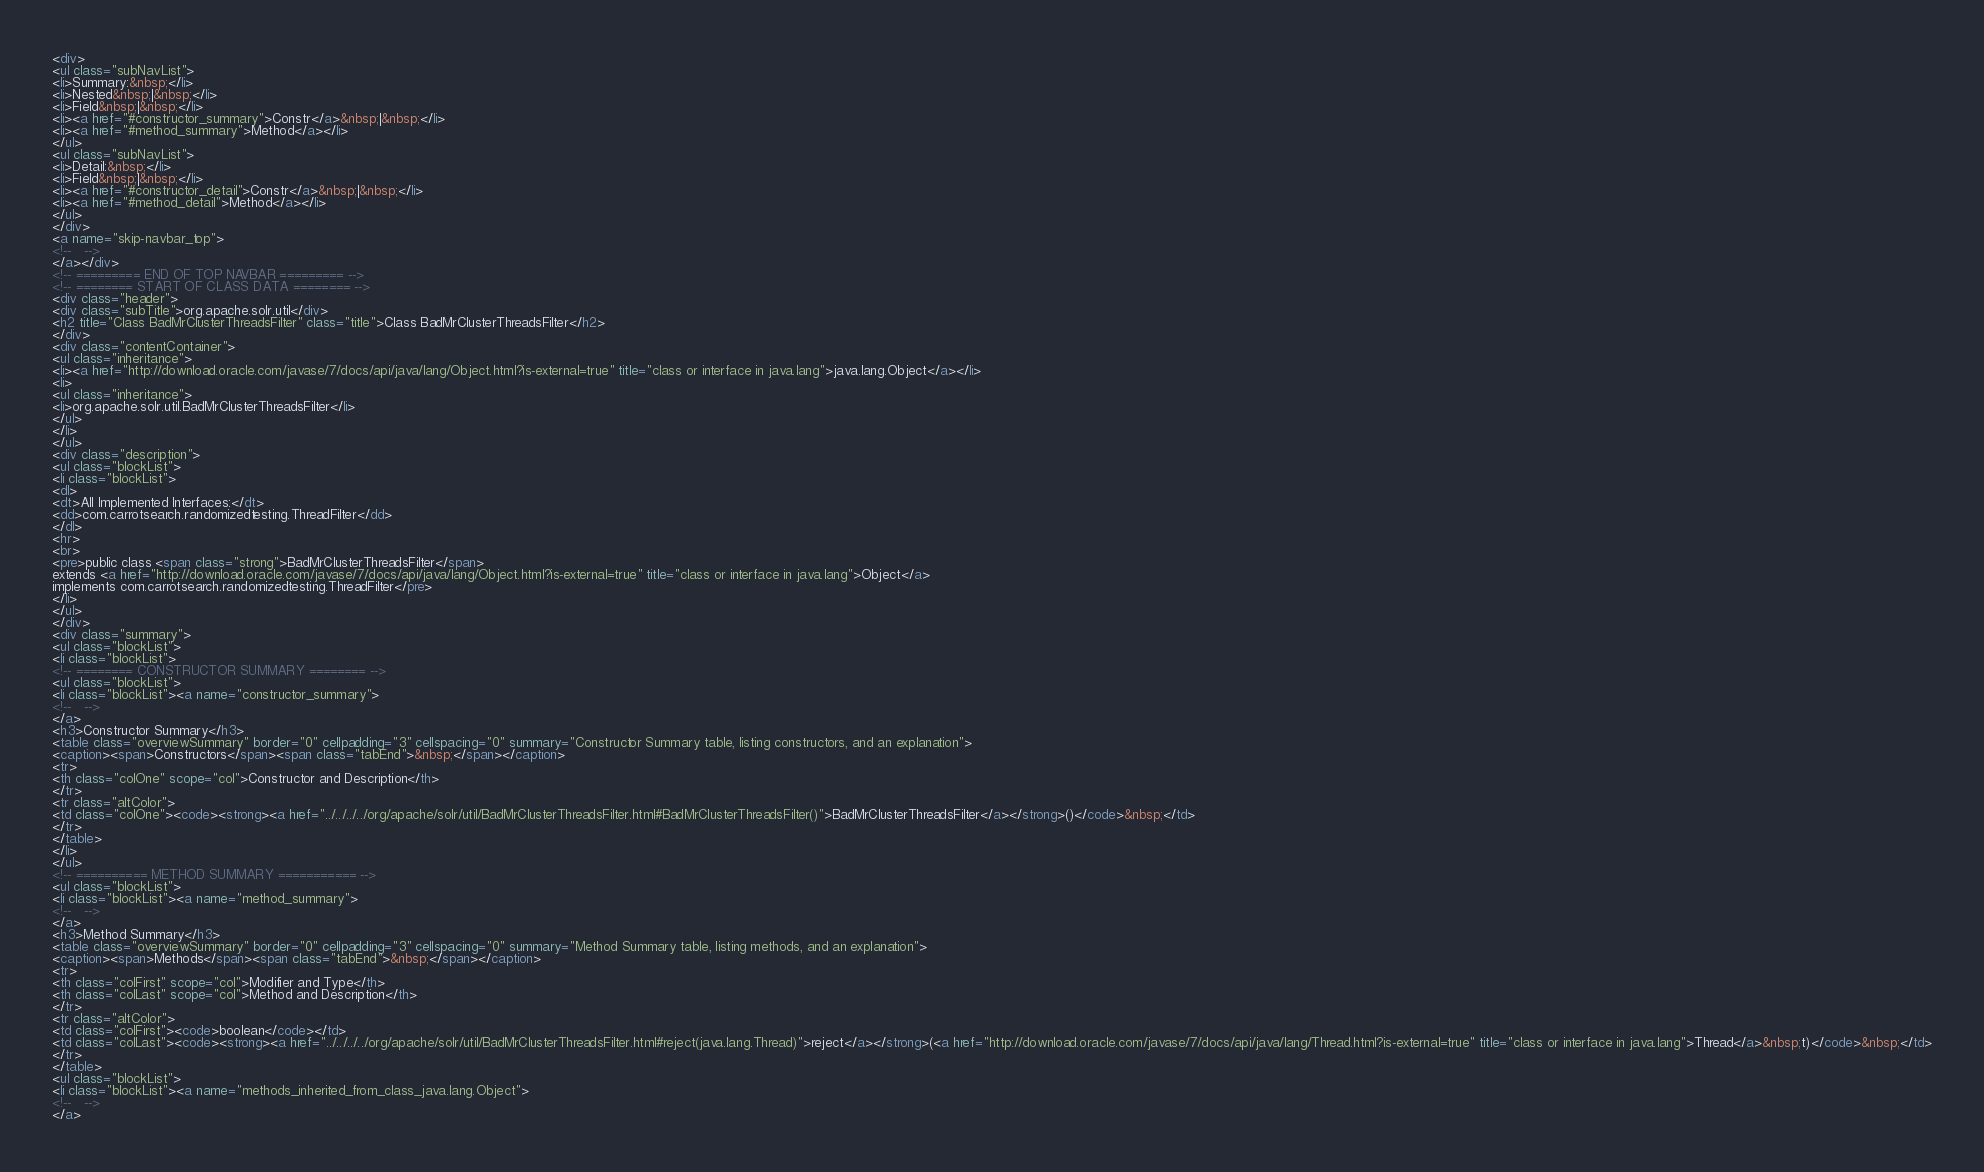Convert code to text. <code><loc_0><loc_0><loc_500><loc_500><_HTML_><div>
<ul class="subNavList">
<li>Summary:&nbsp;</li>
<li>Nested&nbsp;|&nbsp;</li>
<li>Field&nbsp;|&nbsp;</li>
<li><a href="#constructor_summary">Constr</a>&nbsp;|&nbsp;</li>
<li><a href="#method_summary">Method</a></li>
</ul>
<ul class="subNavList">
<li>Detail:&nbsp;</li>
<li>Field&nbsp;|&nbsp;</li>
<li><a href="#constructor_detail">Constr</a>&nbsp;|&nbsp;</li>
<li><a href="#method_detail">Method</a></li>
</ul>
</div>
<a name="skip-navbar_top">
<!--   -->
</a></div>
<!-- ========= END OF TOP NAVBAR ========= -->
<!-- ======== START OF CLASS DATA ======== -->
<div class="header">
<div class="subTitle">org.apache.solr.util</div>
<h2 title="Class BadMrClusterThreadsFilter" class="title">Class BadMrClusterThreadsFilter</h2>
</div>
<div class="contentContainer">
<ul class="inheritance">
<li><a href="http://download.oracle.com/javase/7/docs/api/java/lang/Object.html?is-external=true" title="class or interface in java.lang">java.lang.Object</a></li>
<li>
<ul class="inheritance">
<li>org.apache.solr.util.BadMrClusterThreadsFilter</li>
</ul>
</li>
</ul>
<div class="description">
<ul class="blockList">
<li class="blockList">
<dl>
<dt>All Implemented Interfaces:</dt>
<dd>com.carrotsearch.randomizedtesting.ThreadFilter</dd>
</dl>
<hr>
<br>
<pre>public class <span class="strong">BadMrClusterThreadsFilter</span>
extends <a href="http://download.oracle.com/javase/7/docs/api/java/lang/Object.html?is-external=true" title="class or interface in java.lang">Object</a>
implements com.carrotsearch.randomizedtesting.ThreadFilter</pre>
</li>
</ul>
</div>
<div class="summary">
<ul class="blockList">
<li class="blockList">
<!-- ======== CONSTRUCTOR SUMMARY ======== -->
<ul class="blockList">
<li class="blockList"><a name="constructor_summary">
<!--   -->
</a>
<h3>Constructor Summary</h3>
<table class="overviewSummary" border="0" cellpadding="3" cellspacing="0" summary="Constructor Summary table, listing constructors, and an explanation">
<caption><span>Constructors</span><span class="tabEnd">&nbsp;</span></caption>
<tr>
<th class="colOne" scope="col">Constructor and Description</th>
</tr>
<tr class="altColor">
<td class="colOne"><code><strong><a href="../../../../org/apache/solr/util/BadMrClusterThreadsFilter.html#BadMrClusterThreadsFilter()">BadMrClusterThreadsFilter</a></strong>()</code>&nbsp;</td>
</tr>
</table>
</li>
</ul>
<!-- ========== METHOD SUMMARY =========== -->
<ul class="blockList">
<li class="blockList"><a name="method_summary">
<!--   -->
</a>
<h3>Method Summary</h3>
<table class="overviewSummary" border="0" cellpadding="3" cellspacing="0" summary="Method Summary table, listing methods, and an explanation">
<caption><span>Methods</span><span class="tabEnd">&nbsp;</span></caption>
<tr>
<th class="colFirst" scope="col">Modifier and Type</th>
<th class="colLast" scope="col">Method and Description</th>
</tr>
<tr class="altColor">
<td class="colFirst"><code>boolean</code></td>
<td class="colLast"><code><strong><a href="../../../../org/apache/solr/util/BadMrClusterThreadsFilter.html#reject(java.lang.Thread)">reject</a></strong>(<a href="http://download.oracle.com/javase/7/docs/api/java/lang/Thread.html?is-external=true" title="class or interface in java.lang">Thread</a>&nbsp;t)</code>&nbsp;</td>
</tr>
</table>
<ul class="blockList">
<li class="blockList"><a name="methods_inherited_from_class_java.lang.Object">
<!--   -->
</a></code> 